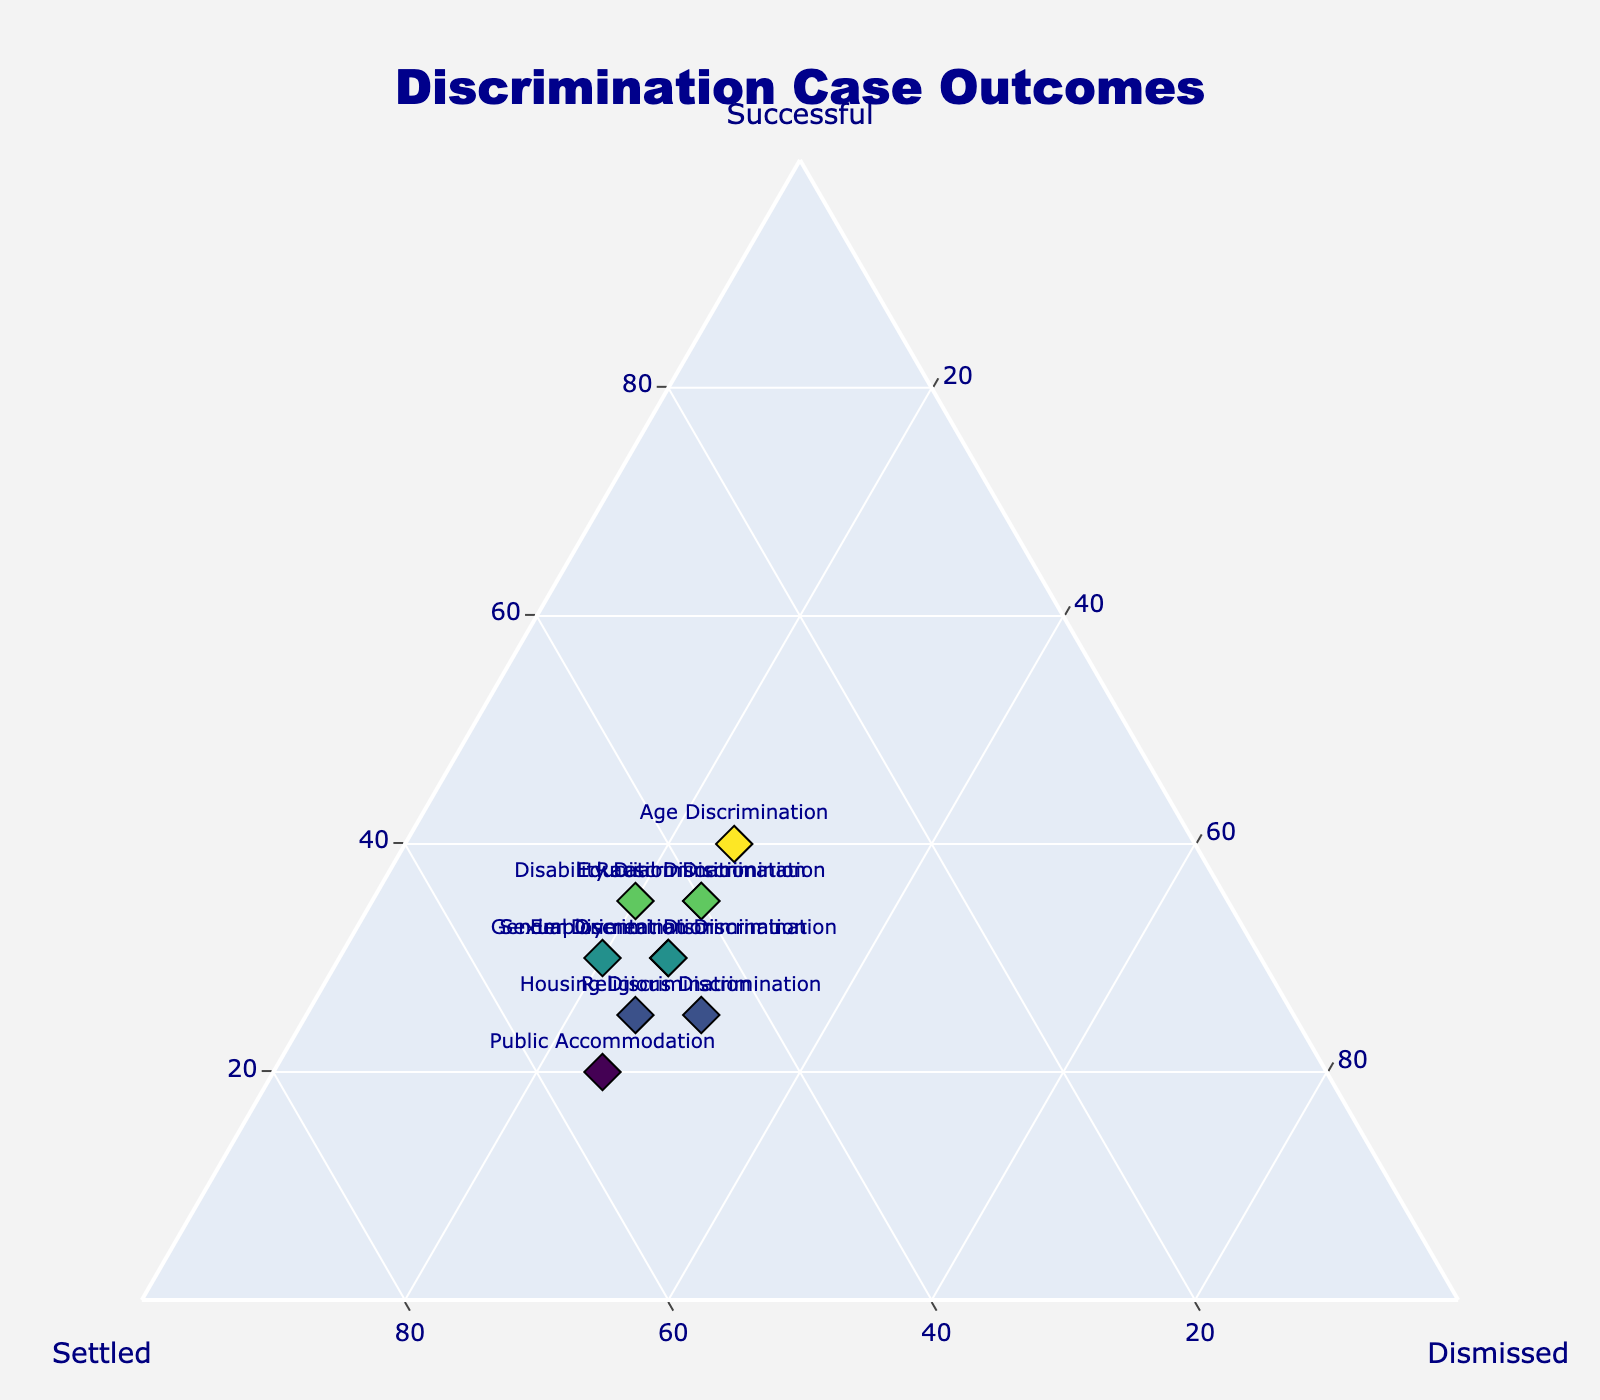What's the title of the figure? The title of the figure is usually prominently displayed at the top. It provides an overview of what the plot represents.
Answer: Discrimination Case Outcomes How many categories of discrimination cases are shown in the plot? By counting the labels present for different markers on the ternary plot, we can determine the total number of categories.
Answer: 10 Which type of discrimination has the highest percentage of successful cases? By examining the position of the markers along the 'Successful' axis, we can identify the category with the highest score.
Answer: Age Discrimination Which type of discrimination has an equal percentage of case outcomes being settled and dismissed? We need to find the category marker that falls in the line where the 'Settled' and 'Dismissed' scores are equal.
Answer: Housing Discrimination What is the combined percentage of settled and dismissed cases for Public Accommodation discrimination? To find the combined percentage, add the 'Settled' and 'Dismissed' values for Public Accommodation discrimination: 55 (Settled) + 25 (Dismissed).
Answer: 80 Among the categories, which has the most balanced outcomes in terms of successful, settled, and dismissed cases? By examining the markers, identify the category closest to the center of the plot, where all three outcomes are balanced.
Answer: Employment Discrimination What color is used for the markers, and what does the color represent? The color of the markers is based on the 'Successful' percentage value, as indicated by the color scale. The color varies from the Viridis scale.
Answer: Viridis scale representing 'Successful' percentage For Disability Discrimination cases, by how many percentage points does the 'Settled' outcome exceed the 'Successful' outcome? By subtracting the percentage of 'Successful' cases (35) from the 'Settled' cases (45), we get the difference.
Answer: 10 Which types of discrimination show a 25% dismissal rate? By observing the markers along the 'Dismissed' axis at the 25% point, we can list the corresponding categories.
Answer: Employment, Housing, Education, Public Accommodation, Racial, Sexual Orientation Discrimination If you average the percentage of successful outcomes across all types of discrimination shown, what value do you get? To find the average, add all 'Successful' percentages and divide by the number of categories: (30+25+35+20+40+35+30+35+25+30)/10.
Answer: 30.5 